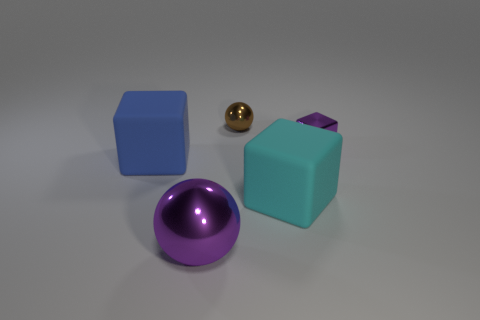Are there any patterns or textures visible on the surfaces of these objects? The surfaces of the objects in the image appear to be relatively textureless and smooth, with no discernible patterns. This minimalistic design gives the objects a clean and simplistic aesthetic. 